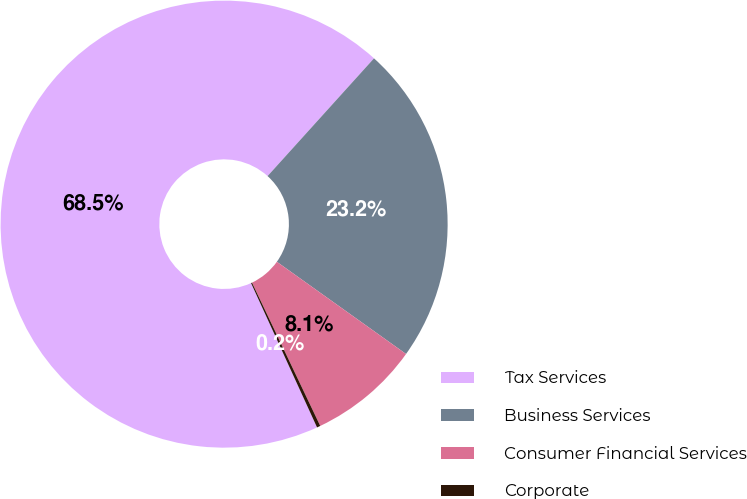Convert chart. <chart><loc_0><loc_0><loc_500><loc_500><pie_chart><fcel>Tax Services<fcel>Business Services<fcel>Consumer Financial Services<fcel>Corporate<nl><fcel>68.53%<fcel>23.17%<fcel>8.06%<fcel>0.25%<nl></chart> 